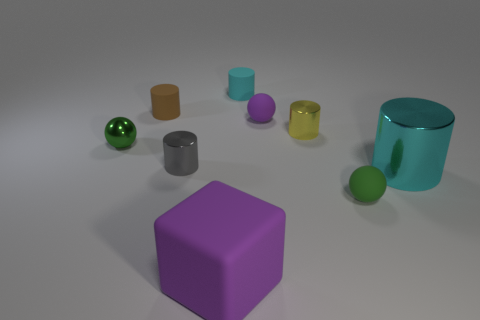Subtract all red cylinders. Subtract all blue balls. How many cylinders are left? 5 Subtract all gray cubes. How many brown cylinders are left? 1 Add 7 objects. How many large greens exist? 0 Subtract all big green shiny balls. Subtract all green spheres. How many objects are left? 7 Add 7 large metal things. How many large metal things are left? 8 Add 2 small gray shiny cylinders. How many small gray shiny cylinders exist? 3 Add 1 tiny purple matte spheres. How many objects exist? 10 Subtract all purple balls. How many balls are left? 2 Subtract all gray cylinders. How many cylinders are left? 4 Subtract 1 green spheres. How many objects are left? 8 